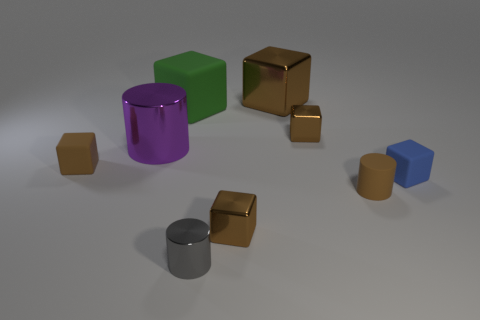What is the texture of the objects like? All objects exhibit a smooth texture, but the metallic objects have a reflective surface that gives them a shiny appearance, contrasting with the matte finish of the green cube and the blue cuboid. 